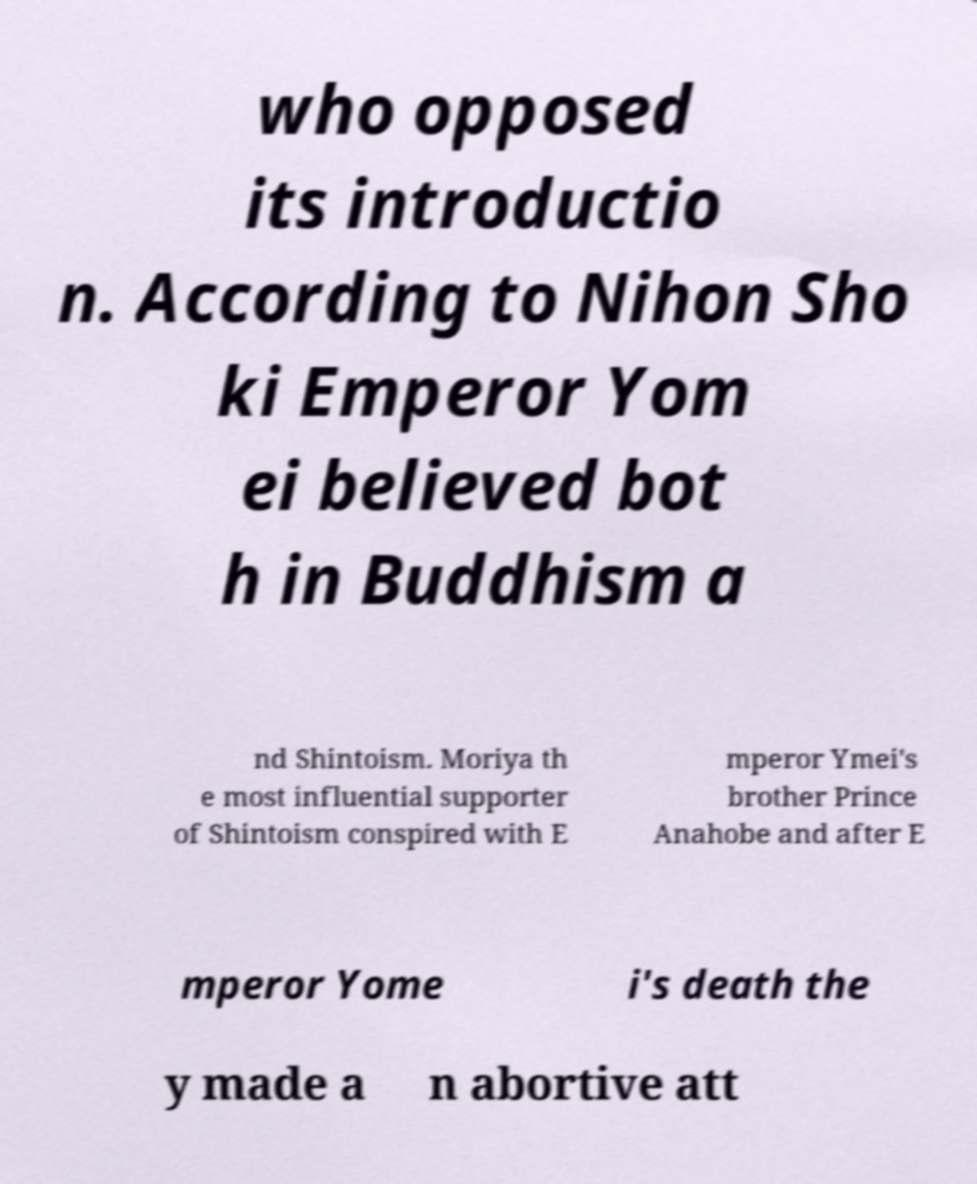Please identify and transcribe the text found in this image. who opposed its introductio n. According to Nihon Sho ki Emperor Yom ei believed bot h in Buddhism a nd Shintoism. Moriya th e most influential supporter of Shintoism conspired with E mperor Ymei's brother Prince Anahobe and after E mperor Yome i's death the y made a n abortive att 